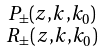<formula> <loc_0><loc_0><loc_500><loc_500>\begin{smallmatrix} P _ { \pm } ( z , k , k _ { 0 } ) \\ R _ { \pm } ( z , k , k _ { 0 } ) \end{smallmatrix}</formula> 